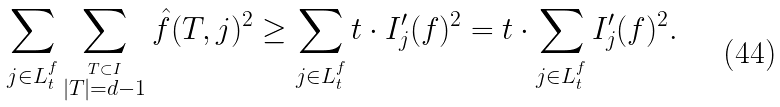Convert formula to latex. <formula><loc_0><loc_0><loc_500><loc_500>\sum _ { j \in L ^ { f } _ { t } } \sum _ { \stackrel { T \subset I } { | T | = d - 1 } } \hat { f } ( T , j ) ^ { 2 } \geq \sum _ { j \in L ^ { f } _ { t } } t \cdot I ^ { \prime } _ { j } ( f ) ^ { 2 } = t \cdot \sum _ { j \in L ^ { f } _ { t } } I ^ { \prime } _ { j } ( f ) ^ { 2 } .</formula> 